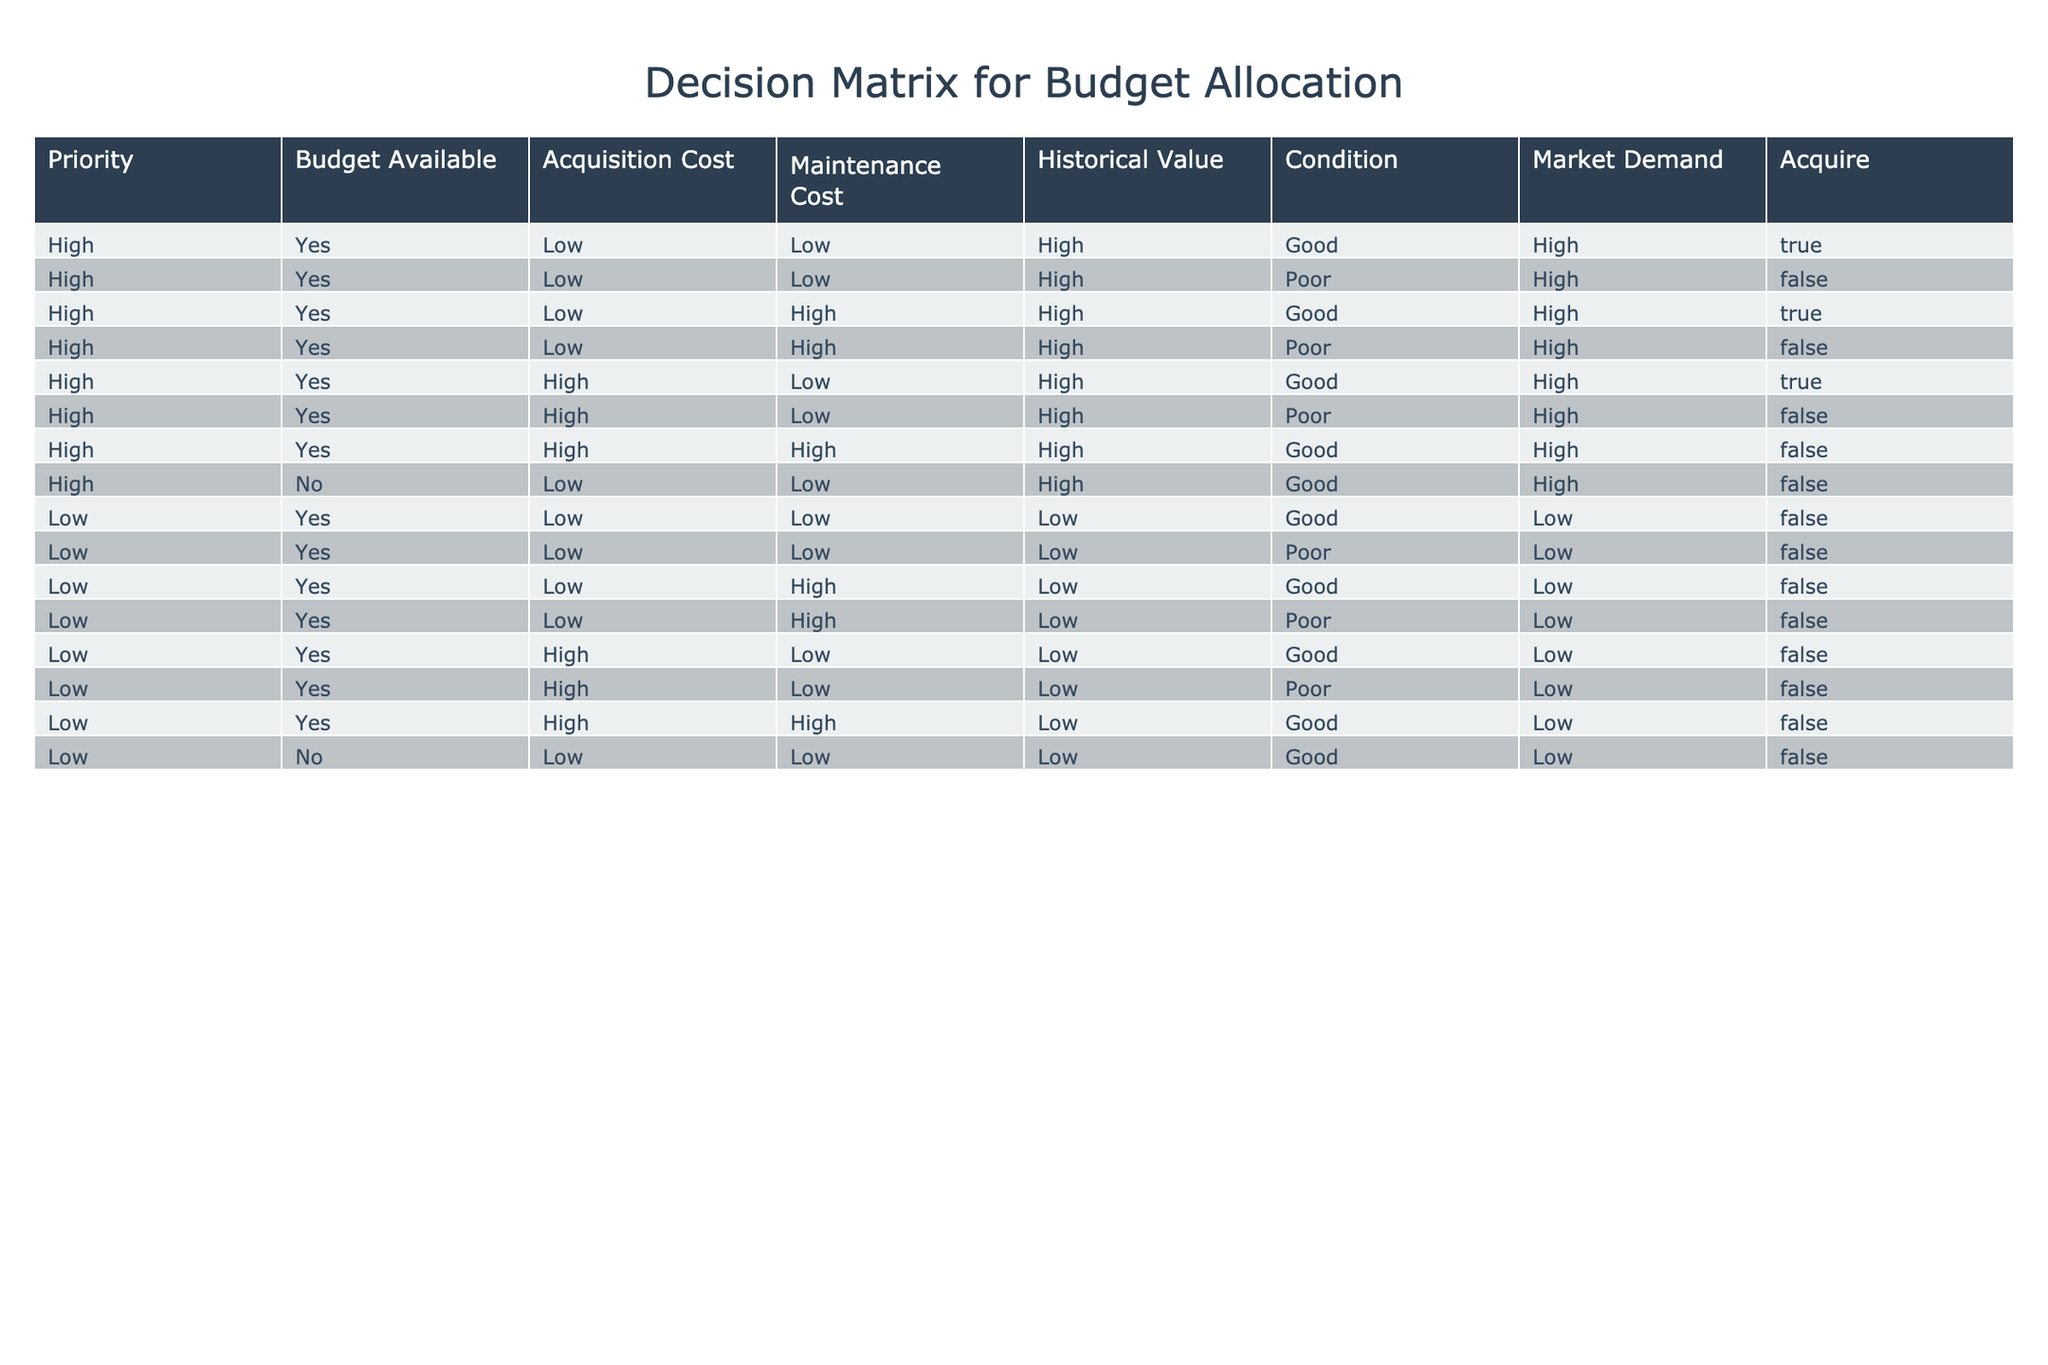What is the total number of rows where the acquisition is approved? There are 4 rows in the table where "Acquire" is marked as True. These rows can be found by filtering the "Acquire" column for True values and counting the occurrences.
Answer: 4 Is the maintenance cost higher than the acquisition cost for any high-priority entries? By comparing the "Acquisition Cost" and "Maintenance Cost" for all high-priority entries, the rows where maintenance cost is higher than acquisition cost should be evaluated. The only row with "High, Yes, Low, High" indicates that both the acquisition and maintenance costs are present, yet the maintenance cost is high while acquisition cost is low, implying that in this case, acquisition cost is less than maintenance cost. So, there are no rows fitting this condition for the high-priority entries.
Answer: No What proportion of the low-priority entries has a high historical value? There are 7 low-priority entries, and only 1 of them has "High" listed under "Historical Value." The proportion is calculated by dividing the count of low-priority entries with high historical value by the total number of low-priority entries, which is 1/7.
Answer: Approximately 14% Are there any rows where acquisition is rejected but the market demand is high? Yes, there are rows where "Acquire" is False and "Market Demand" is High. A careful examination of the table shows that there are 2 cases that meet this criterion. In these instances, although the market demand is high, the acquisition is not approved due to other factors such as condition or cost.
Answer: Yes What are the conditions of the entries where acquisition is approved? Looking specifically at the rows where "Acquire" is True, there are 3 distinct conditions present: "Good" for the first two entries and "Poor" for the next remaining entry. Thus, the conditions from the approved entries are extracted from these rows directly.
Answer: Good, Poor What is the average maintenance cost for the high-priority entries? The maintenance costs for the high-priority entries are Low, High, Low, High, which translates to two Low and two High. To determine the average, we can assume a numerical representation (Low=1, High=2) and calculate (1 + 2 + 1 + 2) / 4 = 1.5.
Answer: 1.5 Is any low-priority entry both in good condition and has low acquisition cost? Among the low-priority entries, there are two instances where the condition is marked as "Good" and both have "Low" acquisition cost. This indicates approval for a low acquisition under favorable conditions.
Answer: Yes What is the difference in acquisition costs between high-priority and low-priority entries? To find the difference in acquisition costs, we sum the acquisition costs for high-priority (2 Low + 2 High; assume Low=1, High=2, total = 5) and low-priority (3 Low + 0 High; assume Low=1, High=0 total = 3). Then, we find the difference between high-priority total and low-priority total which becomes 5 - 3 = 2.
Answer: 2 